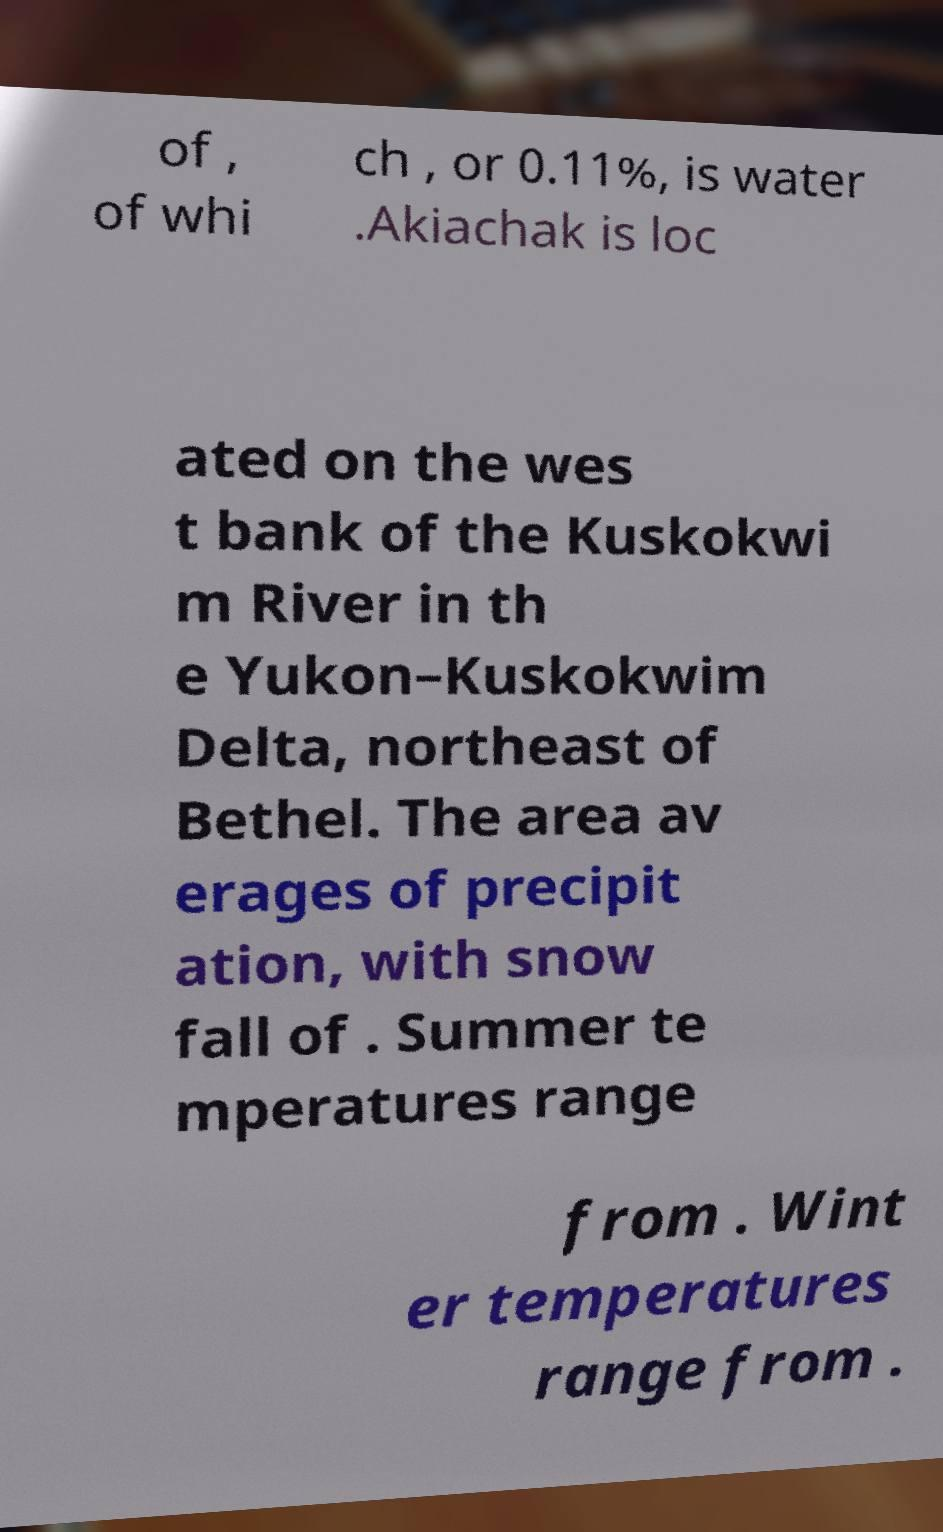Could you assist in decoding the text presented in this image and type it out clearly? of , of whi ch , or 0.11%, is water .Akiachak is loc ated on the wes t bank of the Kuskokwi m River in th e Yukon–Kuskokwim Delta, northeast of Bethel. The area av erages of precipit ation, with snow fall of . Summer te mperatures range from . Wint er temperatures range from . 